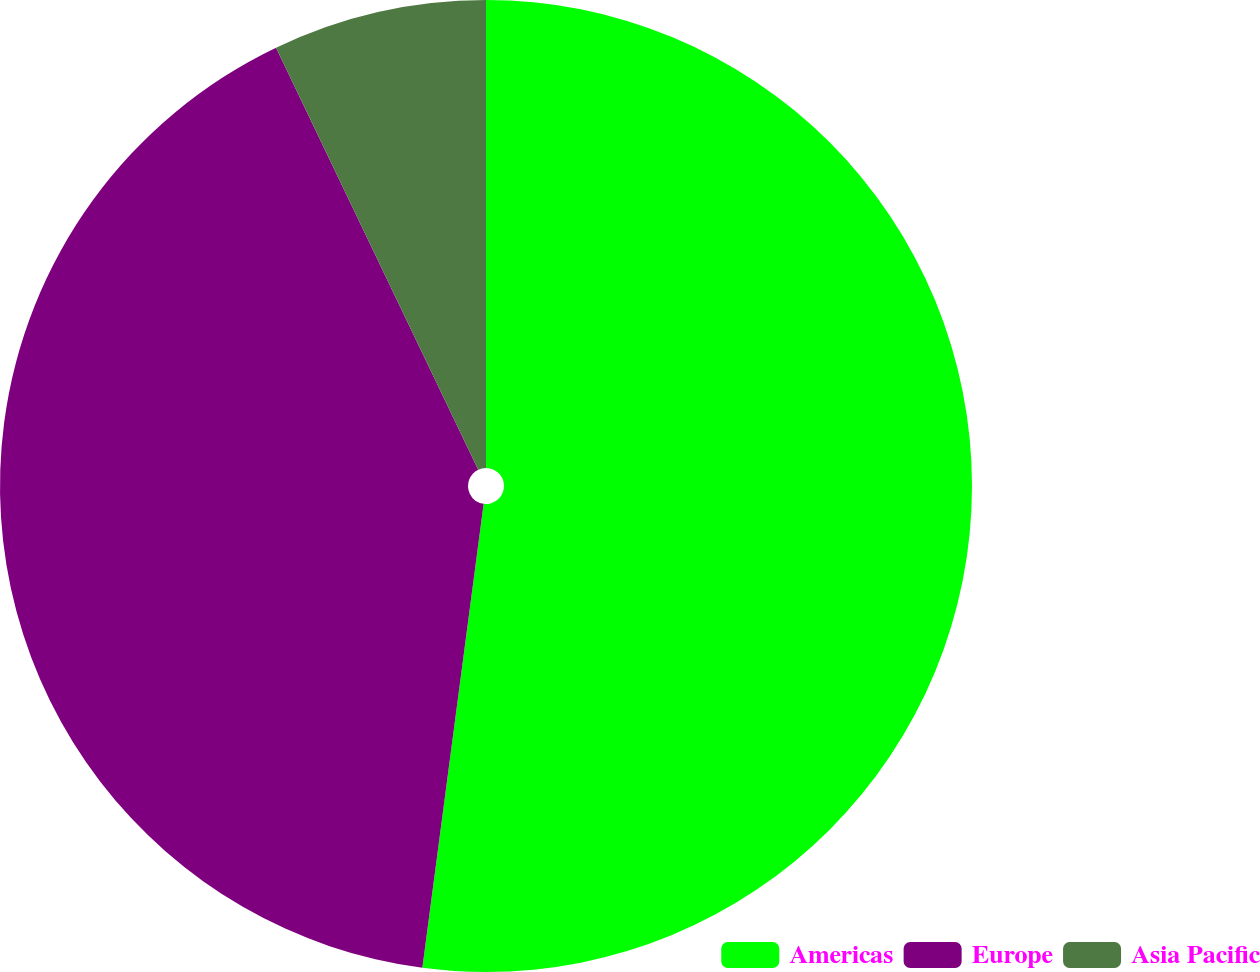Convert chart. <chart><loc_0><loc_0><loc_500><loc_500><pie_chart><fcel>Americas<fcel>Europe<fcel>Asia Pacific<nl><fcel>52.09%<fcel>40.8%<fcel>7.11%<nl></chart> 